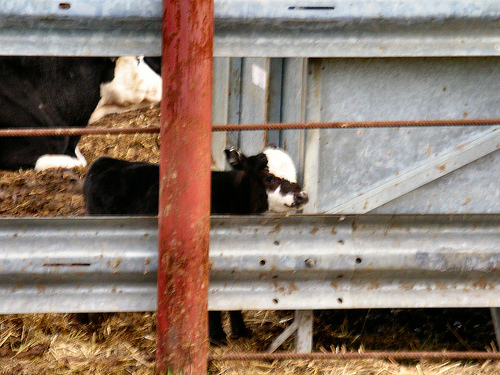<image>
Can you confirm if the cow is on the railing? No. The cow is not positioned on the railing. They may be near each other, but the cow is not supported by or resting on top of the railing. 